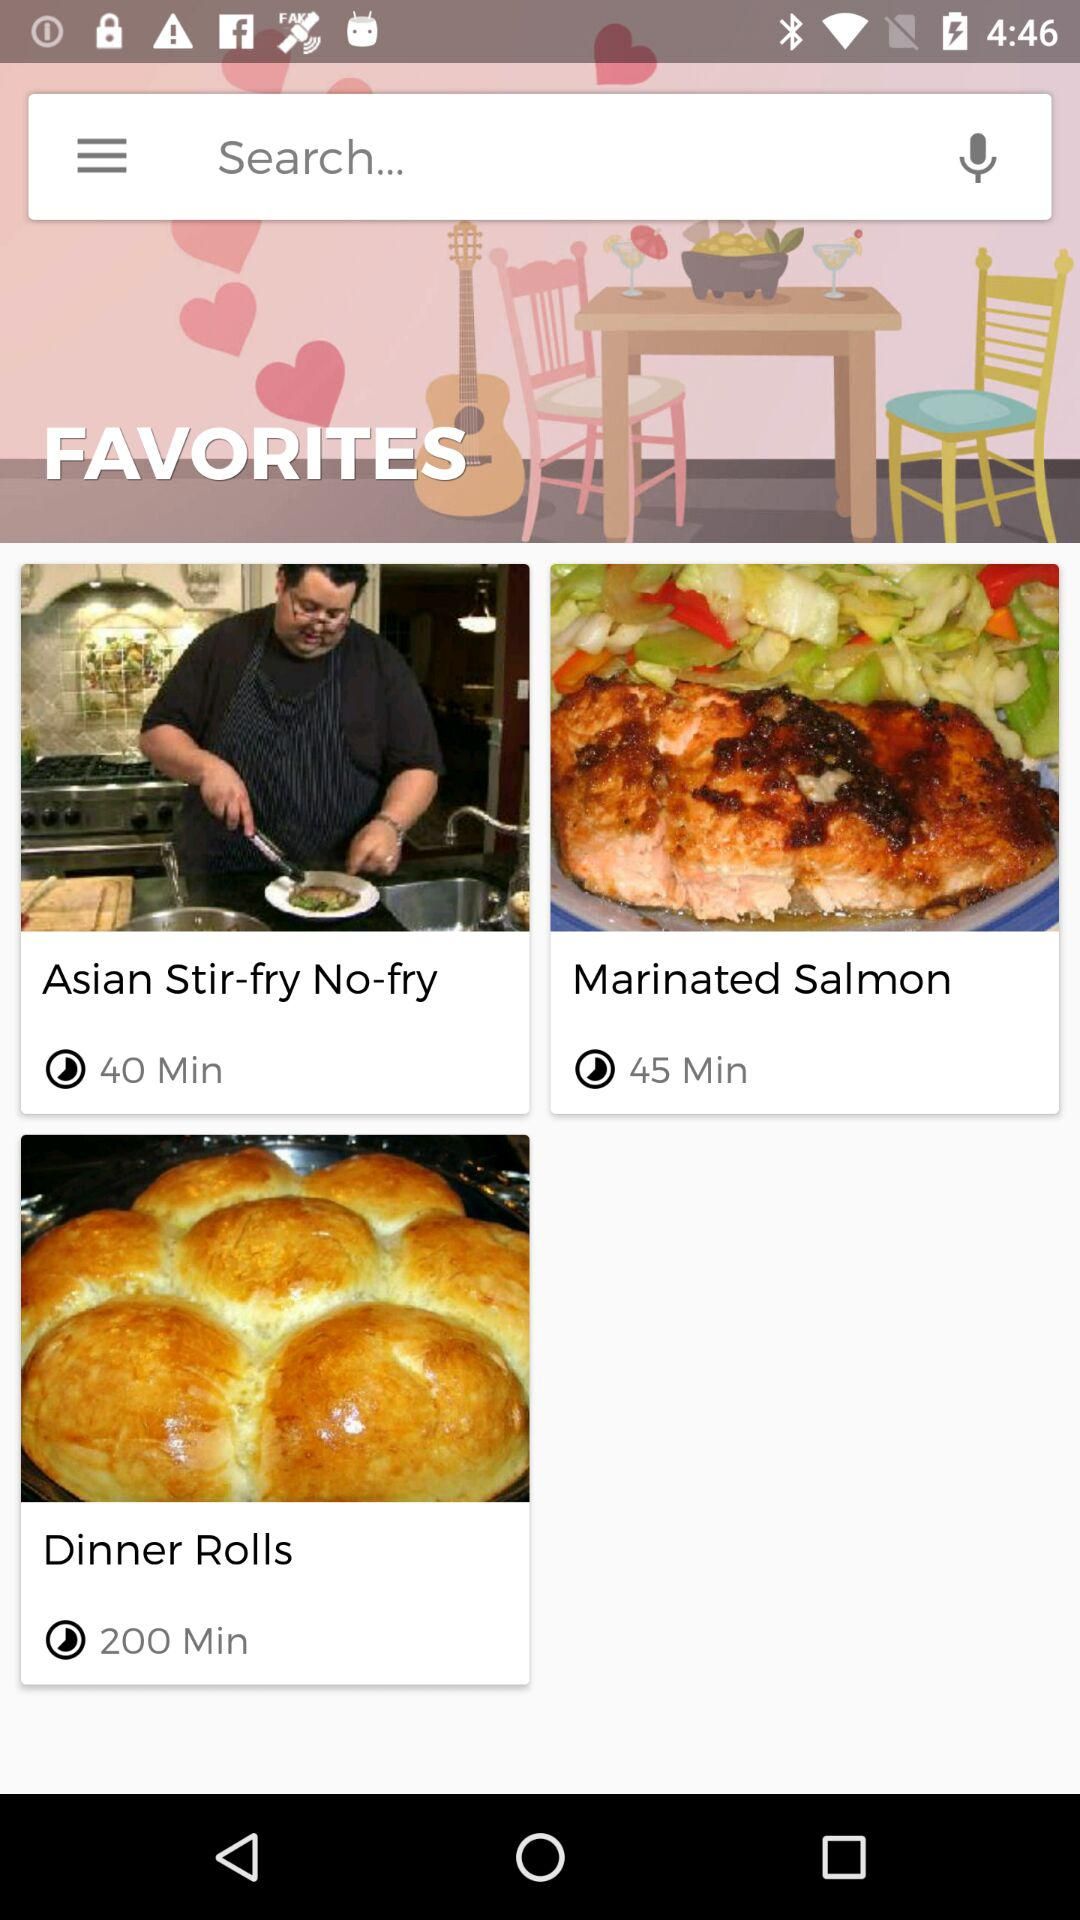How many minutes longer does it take to make the dinner rolls than the salmon?
Answer the question using a single word or phrase. 155 